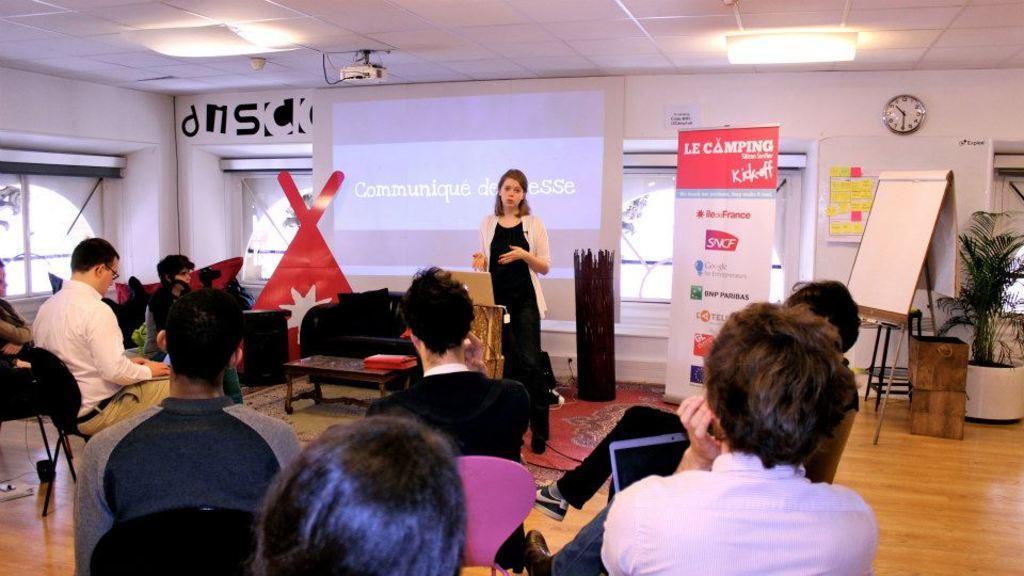How would you summarize this image in a sentence or two? As we can see in the image there is a wall, window, screen, plant, board, banner, few people here and there, chairs, sofa, table and a projector. 